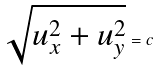Convert formula to latex. <formula><loc_0><loc_0><loc_500><loc_500>\sqrt { u _ { x } ^ { 2 } + u _ { y } ^ { 2 } } = c</formula> 